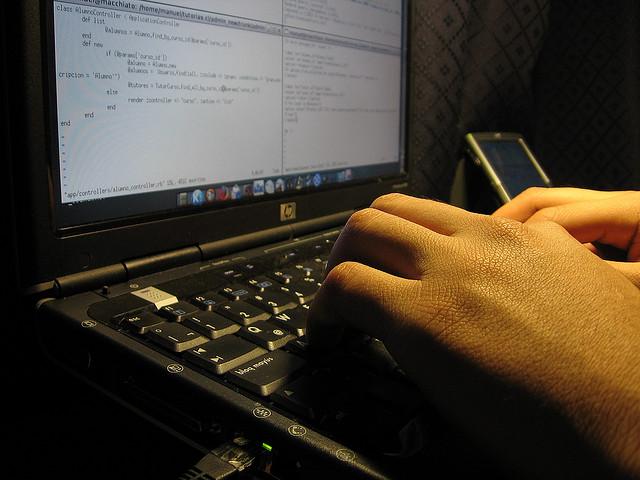What is to the right side of the computer keyboard?
Quick response, please. Phone. What is on the screen?
Answer briefly. Data. Is the computer turned on?
Answer briefly. Yes. How many dogs are depicted?
Quick response, please. 0. 